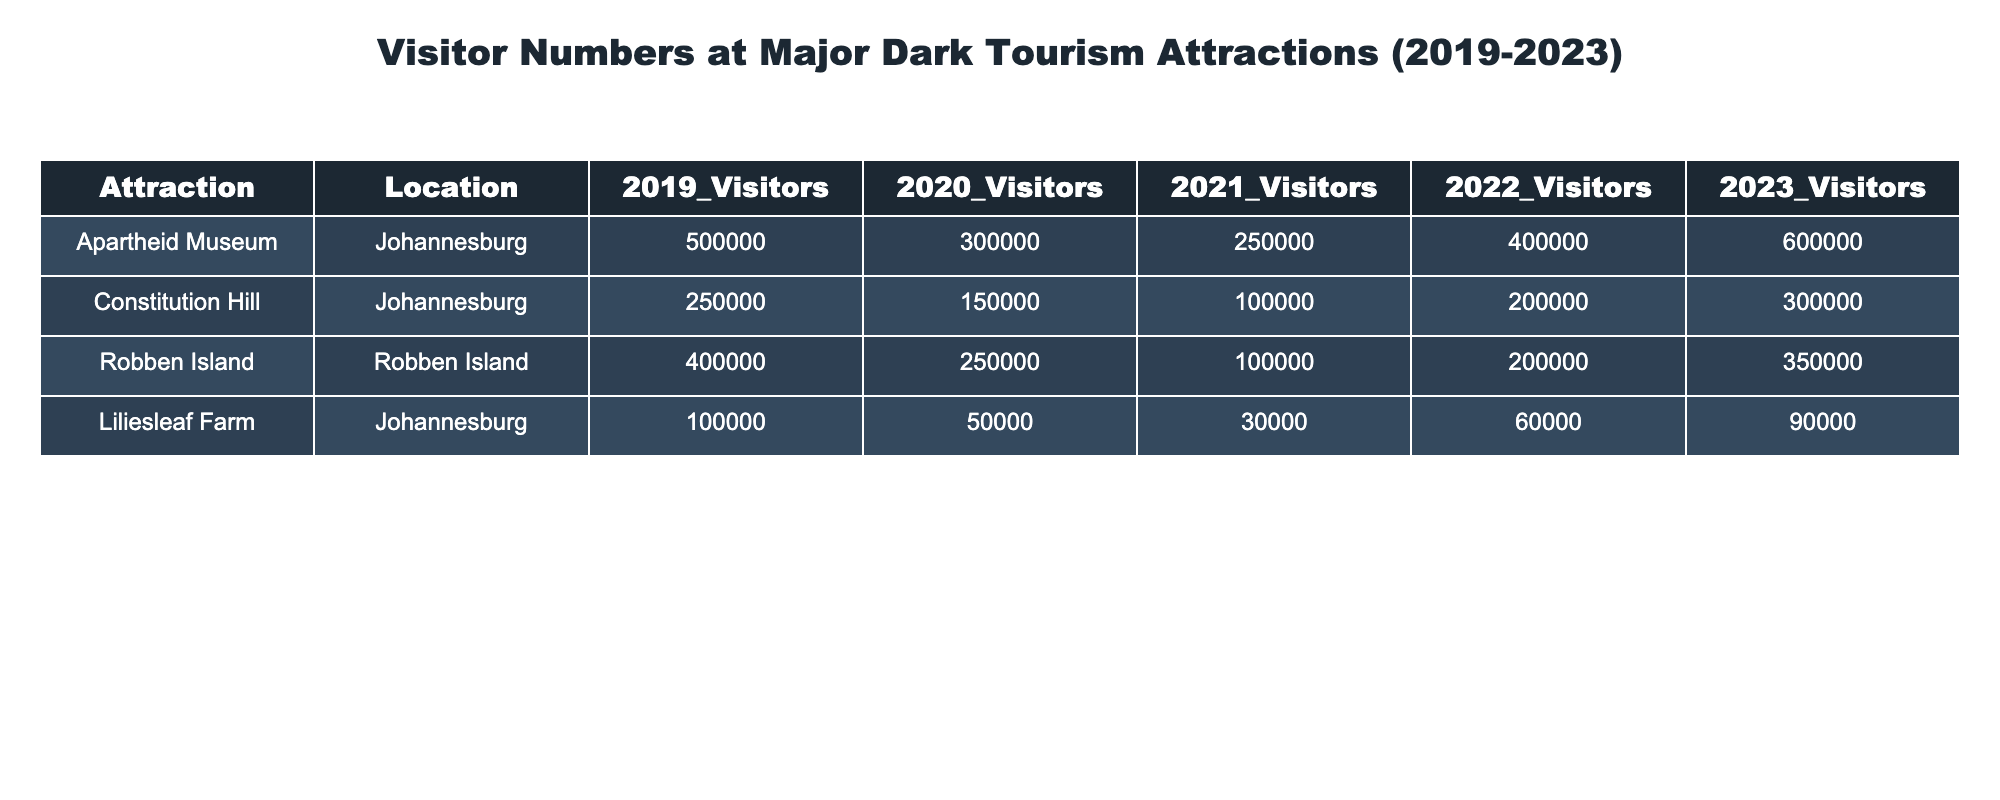What was the number of visitors to the Apartheid Museum in 2022? The table shows that the number of visitors to the Apartheid Museum in 2022 was 400,000.
Answer: 400,000 In which year did Liliesleaf Farm see the lowest number of visitors? According to the table, Liliesleaf Farm had the lowest number of visitors in 2021, with only 30,000 visitors.
Answer: 2021 What is the total number of visitors to Constitution Hill over the five years? To find the total, we sum each year's visitors: 250,000 + 150,000 + 100,000 + 200,000 + 300,000 = 1,000,000.
Answer: 1,000,000 Did Robben Island experience an increase in visitors from 2022 to 2023? The number of visitors to Robben Island increased from 200,000 in 2022 to 350,000 in 2023, indicating a yes.
Answer: Yes What year had the highest visitor count for the Apartheid Museum? From the data, 2019 had the highest visitor count for the Apartheid Museum with 500,000 visitors, followed by 2023 with 600,000. Thus, the highest year was 2023.
Answer: 2023 What is the average number of visitors to Liliesleaf Farm across the five years? To calculate the average, sum the visitors for each year: 100,000 + 50,000 + 30,000 + 60,000 + 90,000 = 330,000. Then divide by 5: 330,000 / 5 = 66,000.
Answer: 66,000 Which attraction has consistently maintained over 200,000 visitors in 2023? In the table, both the Apartheid Museum (600,000) and Robben Island (350,000) maintained over 200,000 visitors in 2023, while Constitution Hill (300,000) also exceeded this number.
Answer: Apartheid Museum, Robben Island, and Constitution Hill What is the visitor growth for the Apartheid Museum from 2019 to 2023? The visitors in 2019 were 500,000, and in 2023 they were 600,000. The growth can be found by subtracting: 600,000 - 500,000 = 100,000.
Answer: 100,000 